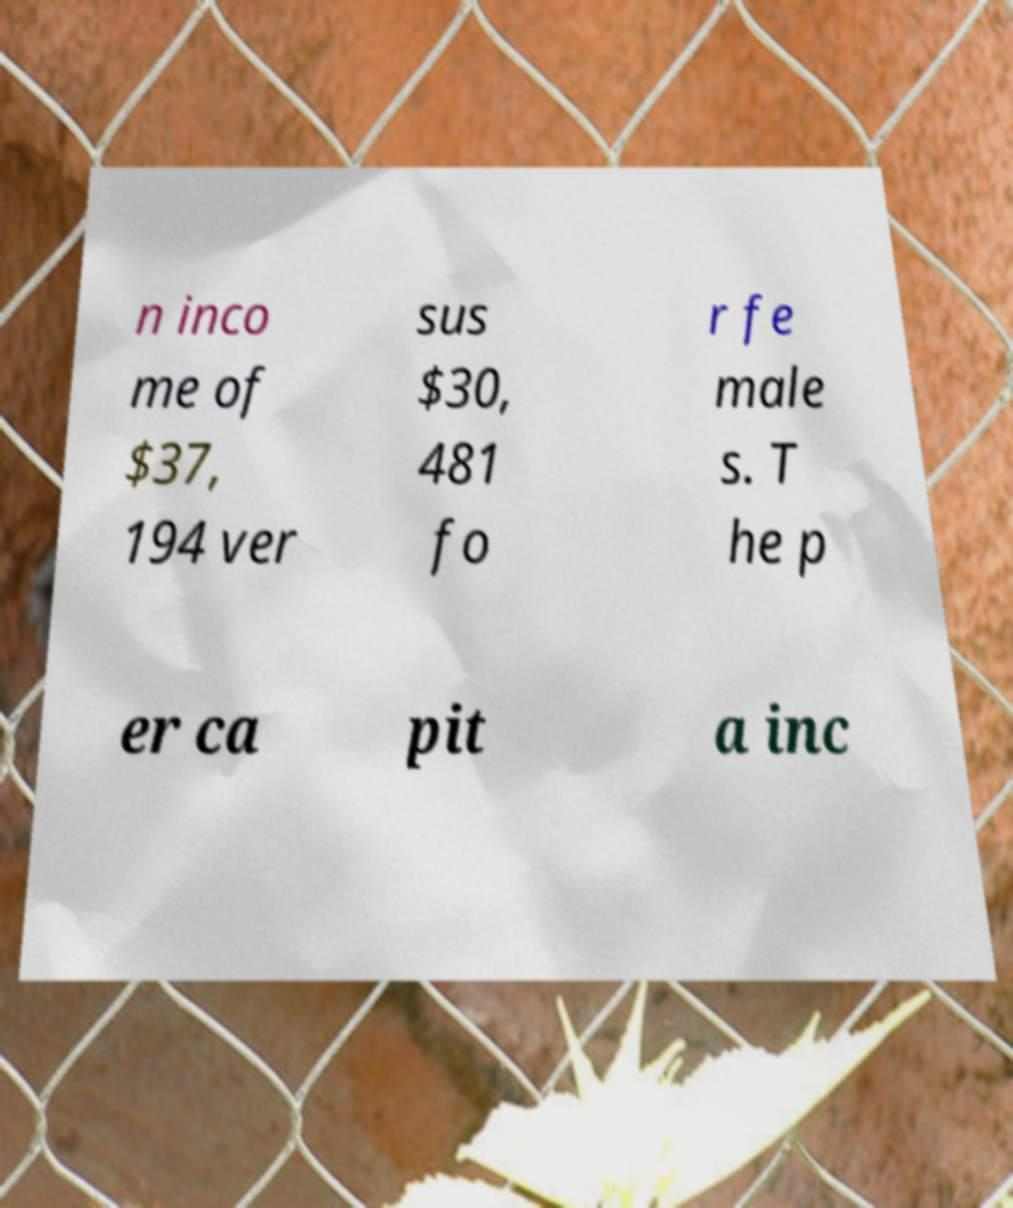There's text embedded in this image that I need extracted. Can you transcribe it verbatim? n inco me of $37, 194 ver sus $30, 481 fo r fe male s. T he p er ca pit a inc 